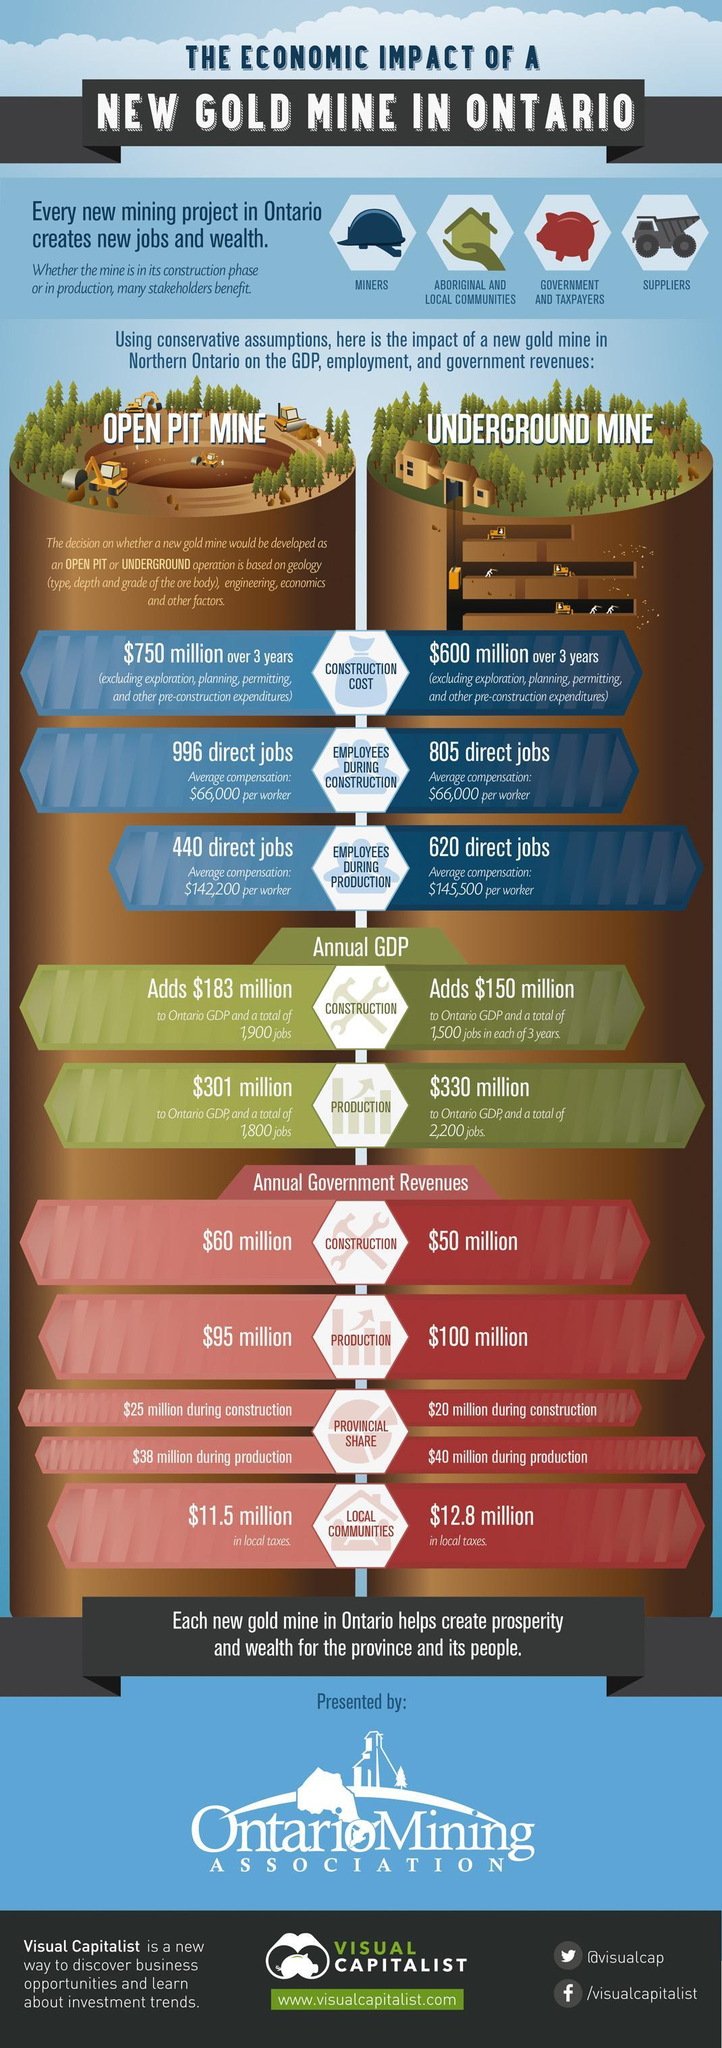What is the average compensation per worker in the production phase of an open pit gold mine in Northern Ontario?
Answer the question with a short phrase. $142,200 What is the average compensation per worker in the construction phase of an open pit gold mine in Northern Ontario? $66,000 How many direct jobs will be available during the production phase of an underground gold mine in Northern Ontario? 620 direct jobs What will be annual government revenue during the production phase of an open pit gold mine in Northern Ontario? $95 million What will be annual government revenue during the construction phase of an underground gold mine in Northern Ontario? $50 million What will be the construction cost  over 3 years for developing an underground gold mine in Northern Ontario? $600 million How many direct jobs  will be available during the construction phase of an open pit gold mine in Northern Ontario? 996 direct jobs How much value is added to the annual GDP of Ontario during the production phase of an open pit gold mine in Northern Ontario? $301 million What is the average compensation per worker in the construction phase of an underground gold mine in Northern Ontario? $66,000 How much value is added to the annual GDP of Ontario during the construction phase of an underground gold mine in Northern Ontario? $150 million 